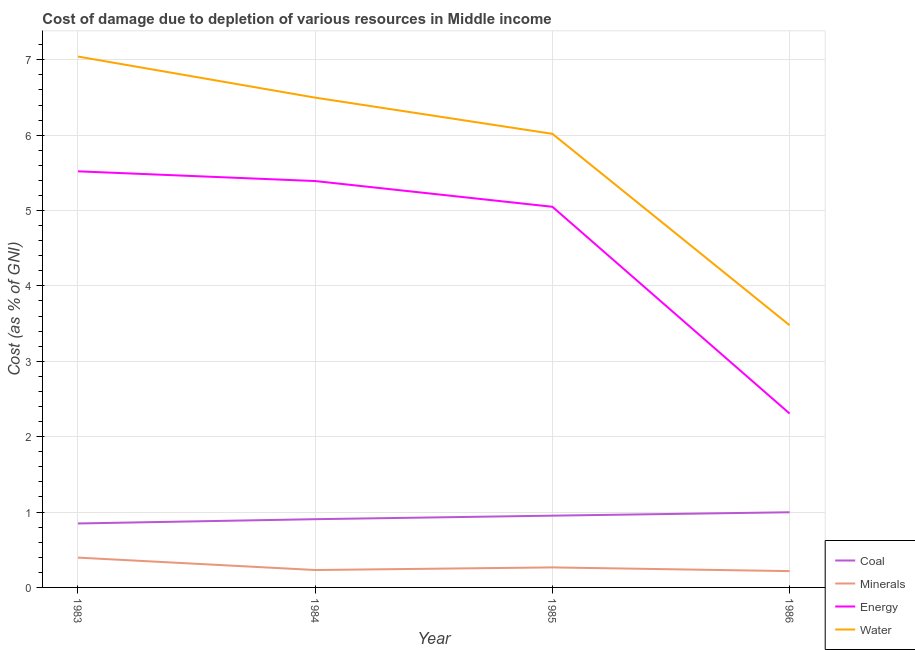How many different coloured lines are there?
Make the answer very short. 4. What is the cost of damage due to depletion of coal in 1983?
Offer a very short reply. 0.85. Across all years, what is the maximum cost of damage due to depletion of water?
Offer a terse response. 7.04. Across all years, what is the minimum cost of damage due to depletion of energy?
Offer a very short reply. 2.31. In which year was the cost of damage due to depletion of minerals minimum?
Offer a very short reply. 1986. What is the total cost of damage due to depletion of coal in the graph?
Keep it short and to the point. 3.7. What is the difference between the cost of damage due to depletion of water in 1985 and that in 1986?
Ensure brevity in your answer.  2.54. What is the difference between the cost of damage due to depletion of coal in 1984 and the cost of damage due to depletion of minerals in 1983?
Make the answer very short. 0.51. What is the average cost of damage due to depletion of energy per year?
Provide a succinct answer. 4.57. In the year 1984, what is the difference between the cost of damage due to depletion of water and cost of damage due to depletion of minerals?
Make the answer very short. 6.27. What is the ratio of the cost of damage due to depletion of water in 1984 to that in 1985?
Ensure brevity in your answer.  1.08. Is the difference between the cost of damage due to depletion of water in 1983 and 1985 greater than the difference between the cost of damage due to depletion of coal in 1983 and 1985?
Offer a very short reply. Yes. What is the difference between the highest and the second highest cost of damage due to depletion of minerals?
Keep it short and to the point. 0.13. What is the difference between the highest and the lowest cost of damage due to depletion of coal?
Provide a short and direct response. 0.15. In how many years, is the cost of damage due to depletion of water greater than the average cost of damage due to depletion of water taken over all years?
Offer a very short reply. 3. Is it the case that in every year, the sum of the cost of damage due to depletion of water and cost of damage due to depletion of energy is greater than the sum of cost of damage due to depletion of minerals and cost of damage due to depletion of coal?
Provide a short and direct response. Yes. Does the cost of damage due to depletion of energy monotonically increase over the years?
Your answer should be compact. No. How many lines are there?
Offer a very short reply. 4. What is the title of the graph?
Keep it short and to the point. Cost of damage due to depletion of various resources in Middle income . What is the label or title of the X-axis?
Your answer should be compact. Year. What is the label or title of the Y-axis?
Offer a very short reply. Cost (as % of GNI). What is the Cost (as % of GNI) in Coal in 1983?
Give a very brief answer. 0.85. What is the Cost (as % of GNI) of Minerals in 1983?
Ensure brevity in your answer.  0.4. What is the Cost (as % of GNI) of Energy in 1983?
Provide a succinct answer. 5.52. What is the Cost (as % of GNI) of Water in 1983?
Provide a short and direct response. 7.04. What is the Cost (as % of GNI) of Coal in 1984?
Offer a terse response. 0.91. What is the Cost (as % of GNI) of Minerals in 1984?
Your answer should be very brief. 0.23. What is the Cost (as % of GNI) in Energy in 1984?
Your answer should be compact. 5.39. What is the Cost (as % of GNI) of Water in 1984?
Offer a very short reply. 6.5. What is the Cost (as % of GNI) in Coal in 1985?
Give a very brief answer. 0.95. What is the Cost (as % of GNI) of Minerals in 1985?
Your answer should be very brief. 0.27. What is the Cost (as % of GNI) in Energy in 1985?
Your answer should be very brief. 5.05. What is the Cost (as % of GNI) in Water in 1985?
Give a very brief answer. 6.02. What is the Cost (as % of GNI) in Coal in 1986?
Your response must be concise. 1. What is the Cost (as % of GNI) in Minerals in 1986?
Make the answer very short. 0.22. What is the Cost (as % of GNI) in Energy in 1986?
Give a very brief answer. 2.31. What is the Cost (as % of GNI) of Water in 1986?
Your response must be concise. 3.48. Across all years, what is the maximum Cost (as % of GNI) of Coal?
Offer a very short reply. 1. Across all years, what is the maximum Cost (as % of GNI) in Minerals?
Offer a terse response. 0.4. Across all years, what is the maximum Cost (as % of GNI) of Energy?
Ensure brevity in your answer.  5.52. Across all years, what is the maximum Cost (as % of GNI) in Water?
Give a very brief answer. 7.04. Across all years, what is the minimum Cost (as % of GNI) in Coal?
Give a very brief answer. 0.85. Across all years, what is the minimum Cost (as % of GNI) of Minerals?
Make the answer very short. 0.22. Across all years, what is the minimum Cost (as % of GNI) of Energy?
Your response must be concise. 2.31. Across all years, what is the minimum Cost (as % of GNI) in Water?
Provide a succinct answer. 3.48. What is the total Cost (as % of GNI) in Coal in the graph?
Ensure brevity in your answer.  3.7. What is the total Cost (as % of GNI) in Minerals in the graph?
Your answer should be very brief. 1.11. What is the total Cost (as % of GNI) of Energy in the graph?
Give a very brief answer. 18.27. What is the total Cost (as % of GNI) of Water in the graph?
Keep it short and to the point. 23.04. What is the difference between the Cost (as % of GNI) in Coal in 1983 and that in 1984?
Make the answer very short. -0.06. What is the difference between the Cost (as % of GNI) of Minerals in 1983 and that in 1984?
Your response must be concise. 0.16. What is the difference between the Cost (as % of GNI) of Energy in 1983 and that in 1984?
Make the answer very short. 0.13. What is the difference between the Cost (as % of GNI) of Water in 1983 and that in 1984?
Provide a short and direct response. 0.55. What is the difference between the Cost (as % of GNI) in Coal in 1983 and that in 1985?
Your response must be concise. -0.1. What is the difference between the Cost (as % of GNI) of Minerals in 1983 and that in 1985?
Keep it short and to the point. 0.13. What is the difference between the Cost (as % of GNI) of Energy in 1983 and that in 1985?
Your response must be concise. 0.47. What is the difference between the Cost (as % of GNI) in Water in 1983 and that in 1985?
Provide a short and direct response. 1.03. What is the difference between the Cost (as % of GNI) in Coal in 1983 and that in 1986?
Offer a very short reply. -0.15. What is the difference between the Cost (as % of GNI) in Minerals in 1983 and that in 1986?
Provide a short and direct response. 0.18. What is the difference between the Cost (as % of GNI) in Energy in 1983 and that in 1986?
Ensure brevity in your answer.  3.21. What is the difference between the Cost (as % of GNI) in Water in 1983 and that in 1986?
Your response must be concise. 3.57. What is the difference between the Cost (as % of GNI) of Coal in 1984 and that in 1985?
Make the answer very short. -0.05. What is the difference between the Cost (as % of GNI) of Minerals in 1984 and that in 1985?
Provide a short and direct response. -0.03. What is the difference between the Cost (as % of GNI) of Energy in 1984 and that in 1985?
Your response must be concise. 0.34. What is the difference between the Cost (as % of GNI) in Water in 1984 and that in 1985?
Make the answer very short. 0.48. What is the difference between the Cost (as % of GNI) in Coal in 1984 and that in 1986?
Offer a very short reply. -0.09. What is the difference between the Cost (as % of GNI) of Minerals in 1984 and that in 1986?
Make the answer very short. 0.01. What is the difference between the Cost (as % of GNI) of Energy in 1984 and that in 1986?
Your response must be concise. 3.08. What is the difference between the Cost (as % of GNI) in Water in 1984 and that in 1986?
Provide a succinct answer. 3.02. What is the difference between the Cost (as % of GNI) of Coal in 1985 and that in 1986?
Your answer should be very brief. -0.04. What is the difference between the Cost (as % of GNI) of Minerals in 1985 and that in 1986?
Ensure brevity in your answer.  0.05. What is the difference between the Cost (as % of GNI) of Energy in 1985 and that in 1986?
Keep it short and to the point. 2.74. What is the difference between the Cost (as % of GNI) in Water in 1985 and that in 1986?
Offer a very short reply. 2.54. What is the difference between the Cost (as % of GNI) in Coal in 1983 and the Cost (as % of GNI) in Minerals in 1984?
Make the answer very short. 0.62. What is the difference between the Cost (as % of GNI) in Coal in 1983 and the Cost (as % of GNI) in Energy in 1984?
Give a very brief answer. -4.54. What is the difference between the Cost (as % of GNI) of Coal in 1983 and the Cost (as % of GNI) of Water in 1984?
Provide a short and direct response. -5.65. What is the difference between the Cost (as % of GNI) in Minerals in 1983 and the Cost (as % of GNI) in Energy in 1984?
Ensure brevity in your answer.  -5. What is the difference between the Cost (as % of GNI) in Minerals in 1983 and the Cost (as % of GNI) in Water in 1984?
Make the answer very short. -6.1. What is the difference between the Cost (as % of GNI) of Energy in 1983 and the Cost (as % of GNI) of Water in 1984?
Make the answer very short. -0.98. What is the difference between the Cost (as % of GNI) in Coal in 1983 and the Cost (as % of GNI) in Minerals in 1985?
Make the answer very short. 0.58. What is the difference between the Cost (as % of GNI) in Coal in 1983 and the Cost (as % of GNI) in Energy in 1985?
Keep it short and to the point. -4.2. What is the difference between the Cost (as % of GNI) of Coal in 1983 and the Cost (as % of GNI) of Water in 1985?
Offer a very short reply. -5.17. What is the difference between the Cost (as % of GNI) in Minerals in 1983 and the Cost (as % of GNI) in Energy in 1985?
Your answer should be very brief. -4.65. What is the difference between the Cost (as % of GNI) in Minerals in 1983 and the Cost (as % of GNI) in Water in 1985?
Make the answer very short. -5.62. What is the difference between the Cost (as % of GNI) of Energy in 1983 and the Cost (as % of GNI) of Water in 1985?
Give a very brief answer. -0.5. What is the difference between the Cost (as % of GNI) of Coal in 1983 and the Cost (as % of GNI) of Minerals in 1986?
Provide a succinct answer. 0.63. What is the difference between the Cost (as % of GNI) of Coal in 1983 and the Cost (as % of GNI) of Energy in 1986?
Your answer should be compact. -1.46. What is the difference between the Cost (as % of GNI) of Coal in 1983 and the Cost (as % of GNI) of Water in 1986?
Make the answer very short. -2.63. What is the difference between the Cost (as % of GNI) in Minerals in 1983 and the Cost (as % of GNI) in Energy in 1986?
Your answer should be very brief. -1.91. What is the difference between the Cost (as % of GNI) of Minerals in 1983 and the Cost (as % of GNI) of Water in 1986?
Offer a terse response. -3.08. What is the difference between the Cost (as % of GNI) in Energy in 1983 and the Cost (as % of GNI) in Water in 1986?
Ensure brevity in your answer.  2.04. What is the difference between the Cost (as % of GNI) in Coal in 1984 and the Cost (as % of GNI) in Minerals in 1985?
Provide a short and direct response. 0.64. What is the difference between the Cost (as % of GNI) of Coal in 1984 and the Cost (as % of GNI) of Energy in 1985?
Give a very brief answer. -4.14. What is the difference between the Cost (as % of GNI) in Coal in 1984 and the Cost (as % of GNI) in Water in 1985?
Make the answer very short. -5.11. What is the difference between the Cost (as % of GNI) of Minerals in 1984 and the Cost (as % of GNI) of Energy in 1985?
Offer a terse response. -4.82. What is the difference between the Cost (as % of GNI) in Minerals in 1984 and the Cost (as % of GNI) in Water in 1985?
Your response must be concise. -5.79. What is the difference between the Cost (as % of GNI) in Energy in 1984 and the Cost (as % of GNI) in Water in 1985?
Keep it short and to the point. -0.63. What is the difference between the Cost (as % of GNI) in Coal in 1984 and the Cost (as % of GNI) in Minerals in 1986?
Your answer should be very brief. 0.69. What is the difference between the Cost (as % of GNI) of Coal in 1984 and the Cost (as % of GNI) of Energy in 1986?
Offer a terse response. -1.4. What is the difference between the Cost (as % of GNI) of Coal in 1984 and the Cost (as % of GNI) of Water in 1986?
Make the answer very short. -2.57. What is the difference between the Cost (as % of GNI) of Minerals in 1984 and the Cost (as % of GNI) of Energy in 1986?
Provide a succinct answer. -2.08. What is the difference between the Cost (as % of GNI) of Minerals in 1984 and the Cost (as % of GNI) of Water in 1986?
Your answer should be compact. -3.25. What is the difference between the Cost (as % of GNI) in Energy in 1984 and the Cost (as % of GNI) in Water in 1986?
Your answer should be compact. 1.91. What is the difference between the Cost (as % of GNI) in Coal in 1985 and the Cost (as % of GNI) in Minerals in 1986?
Your answer should be compact. 0.74. What is the difference between the Cost (as % of GNI) of Coal in 1985 and the Cost (as % of GNI) of Energy in 1986?
Your answer should be compact. -1.35. What is the difference between the Cost (as % of GNI) of Coal in 1985 and the Cost (as % of GNI) of Water in 1986?
Your response must be concise. -2.53. What is the difference between the Cost (as % of GNI) in Minerals in 1985 and the Cost (as % of GNI) in Energy in 1986?
Provide a succinct answer. -2.04. What is the difference between the Cost (as % of GNI) in Minerals in 1985 and the Cost (as % of GNI) in Water in 1986?
Offer a very short reply. -3.21. What is the difference between the Cost (as % of GNI) in Energy in 1985 and the Cost (as % of GNI) in Water in 1986?
Keep it short and to the point. 1.57. What is the average Cost (as % of GNI) of Coal per year?
Offer a terse response. 0.93. What is the average Cost (as % of GNI) of Minerals per year?
Your answer should be very brief. 0.28. What is the average Cost (as % of GNI) of Energy per year?
Your response must be concise. 4.57. What is the average Cost (as % of GNI) in Water per year?
Ensure brevity in your answer.  5.76. In the year 1983, what is the difference between the Cost (as % of GNI) in Coal and Cost (as % of GNI) in Minerals?
Provide a succinct answer. 0.45. In the year 1983, what is the difference between the Cost (as % of GNI) in Coal and Cost (as % of GNI) in Energy?
Your answer should be compact. -4.67. In the year 1983, what is the difference between the Cost (as % of GNI) in Coal and Cost (as % of GNI) in Water?
Keep it short and to the point. -6.19. In the year 1983, what is the difference between the Cost (as % of GNI) in Minerals and Cost (as % of GNI) in Energy?
Your response must be concise. -5.12. In the year 1983, what is the difference between the Cost (as % of GNI) of Minerals and Cost (as % of GNI) of Water?
Make the answer very short. -6.65. In the year 1983, what is the difference between the Cost (as % of GNI) in Energy and Cost (as % of GNI) in Water?
Provide a succinct answer. -1.52. In the year 1984, what is the difference between the Cost (as % of GNI) in Coal and Cost (as % of GNI) in Minerals?
Keep it short and to the point. 0.67. In the year 1984, what is the difference between the Cost (as % of GNI) of Coal and Cost (as % of GNI) of Energy?
Your answer should be very brief. -4.49. In the year 1984, what is the difference between the Cost (as % of GNI) of Coal and Cost (as % of GNI) of Water?
Give a very brief answer. -5.59. In the year 1984, what is the difference between the Cost (as % of GNI) of Minerals and Cost (as % of GNI) of Energy?
Your answer should be compact. -5.16. In the year 1984, what is the difference between the Cost (as % of GNI) in Minerals and Cost (as % of GNI) in Water?
Your answer should be very brief. -6.27. In the year 1984, what is the difference between the Cost (as % of GNI) of Energy and Cost (as % of GNI) of Water?
Give a very brief answer. -1.11. In the year 1985, what is the difference between the Cost (as % of GNI) in Coal and Cost (as % of GNI) in Minerals?
Your response must be concise. 0.69. In the year 1985, what is the difference between the Cost (as % of GNI) in Coal and Cost (as % of GNI) in Energy?
Offer a very short reply. -4.1. In the year 1985, what is the difference between the Cost (as % of GNI) in Coal and Cost (as % of GNI) in Water?
Offer a terse response. -5.07. In the year 1985, what is the difference between the Cost (as % of GNI) in Minerals and Cost (as % of GNI) in Energy?
Your answer should be compact. -4.78. In the year 1985, what is the difference between the Cost (as % of GNI) in Minerals and Cost (as % of GNI) in Water?
Make the answer very short. -5.75. In the year 1985, what is the difference between the Cost (as % of GNI) in Energy and Cost (as % of GNI) in Water?
Your answer should be very brief. -0.97. In the year 1986, what is the difference between the Cost (as % of GNI) in Coal and Cost (as % of GNI) in Minerals?
Your answer should be compact. 0.78. In the year 1986, what is the difference between the Cost (as % of GNI) of Coal and Cost (as % of GNI) of Energy?
Your answer should be very brief. -1.31. In the year 1986, what is the difference between the Cost (as % of GNI) of Coal and Cost (as % of GNI) of Water?
Keep it short and to the point. -2.48. In the year 1986, what is the difference between the Cost (as % of GNI) of Minerals and Cost (as % of GNI) of Energy?
Your answer should be compact. -2.09. In the year 1986, what is the difference between the Cost (as % of GNI) of Minerals and Cost (as % of GNI) of Water?
Keep it short and to the point. -3.26. In the year 1986, what is the difference between the Cost (as % of GNI) of Energy and Cost (as % of GNI) of Water?
Give a very brief answer. -1.17. What is the ratio of the Cost (as % of GNI) of Coal in 1983 to that in 1984?
Keep it short and to the point. 0.94. What is the ratio of the Cost (as % of GNI) of Minerals in 1983 to that in 1984?
Your response must be concise. 1.71. What is the ratio of the Cost (as % of GNI) in Energy in 1983 to that in 1984?
Offer a very short reply. 1.02. What is the ratio of the Cost (as % of GNI) of Water in 1983 to that in 1984?
Ensure brevity in your answer.  1.08. What is the ratio of the Cost (as % of GNI) of Coal in 1983 to that in 1985?
Provide a short and direct response. 0.89. What is the ratio of the Cost (as % of GNI) in Minerals in 1983 to that in 1985?
Provide a short and direct response. 1.49. What is the ratio of the Cost (as % of GNI) in Energy in 1983 to that in 1985?
Offer a very short reply. 1.09. What is the ratio of the Cost (as % of GNI) in Water in 1983 to that in 1985?
Ensure brevity in your answer.  1.17. What is the ratio of the Cost (as % of GNI) of Coal in 1983 to that in 1986?
Your response must be concise. 0.85. What is the ratio of the Cost (as % of GNI) of Minerals in 1983 to that in 1986?
Provide a short and direct response. 1.83. What is the ratio of the Cost (as % of GNI) in Energy in 1983 to that in 1986?
Provide a succinct answer. 2.39. What is the ratio of the Cost (as % of GNI) in Water in 1983 to that in 1986?
Offer a terse response. 2.03. What is the ratio of the Cost (as % of GNI) of Coal in 1984 to that in 1985?
Keep it short and to the point. 0.95. What is the ratio of the Cost (as % of GNI) in Minerals in 1984 to that in 1985?
Your answer should be compact. 0.87. What is the ratio of the Cost (as % of GNI) in Energy in 1984 to that in 1985?
Your response must be concise. 1.07. What is the ratio of the Cost (as % of GNI) in Water in 1984 to that in 1985?
Offer a very short reply. 1.08. What is the ratio of the Cost (as % of GNI) of Coal in 1984 to that in 1986?
Your response must be concise. 0.91. What is the ratio of the Cost (as % of GNI) of Minerals in 1984 to that in 1986?
Offer a terse response. 1.07. What is the ratio of the Cost (as % of GNI) in Energy in 1984 to that in 1986?
Offer a very short reply. 2.34. What is the ratio of the Cost (as % of GNI) in Water in 1984 to that in 1986?
Provide a short and direct response. 1.87. What is the ratio of the Cost (as % of GNI) in Coal in 1985 to that in 1986?
Give a very brief answer. 0.95. What is the ratio of the Cost (as % of GNI) of Minerals in 1985 to that in 1986?
Offer a very short reply. 1.23. What is the ratio of the Cost (as % of GNI) of Energy in 1985 to that in 1986?
Give a very brief answer. 2.19. What is the ratio of the Cost (as % of GNI) of Water in 1985 to that in 1986?
Provide a succinct answer. 1.73. What is the difference between the highest and the second highest Cost (as % of GNI) of Coal?
Give a very brief answer. 0.04. What is the difference between the highest and the second highest Cost (as % of GNI) in Minerals?
Your answer should be compact. 0.13. What is the difference between the highest and the second highest Cost (as % of GNI) of Energy?
Your answer should be compact. 0.13. What is the difference between the highest and the second highest Cost (as % of GNI) in Water?
Your answer should be very brief. 0.55. What is the difference between the highest and the lowest Cost (as % of GNI) of Coal?
Offer a very short reply. 0.15. What is the difference between the highest and the lowest Cost (as % of GNI) in Minerals?
Give a very brief answer. 0.18. What is the difference between the highest and the lowest Cost (as % of GNI) in Energy?
Make the answer very short. 3.21. What is the difference between the highest and the lowest Cost (as % of GNI) in Water?
Give a very brief answer. 3.57. 